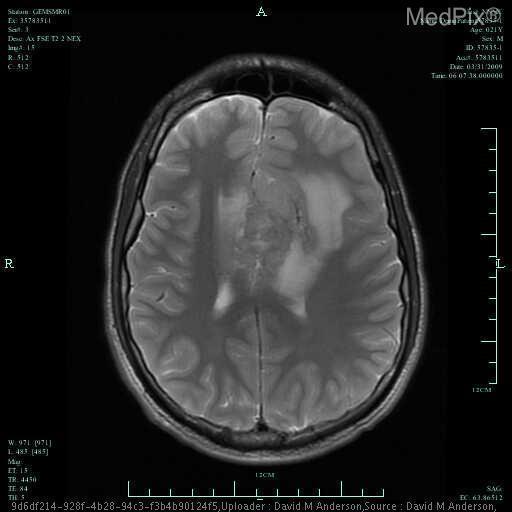Is there mass effect?
Give a very brief answer. Yes. Which is more likely? cancer or hemorrhage?
Be succinct. Hemorrhage. Is this cancer or hemorrhage?
Be succinct. Cancer. Is this a ring enhancing lesion?
Keep it brief. No. Is there ring-enhancement?
Answer briefly. No. Are the dark areas grey or white matter?
Answer briefly. White matter. The dark areas of the image show what type of brain matter?
Answer briefly. White matter. 